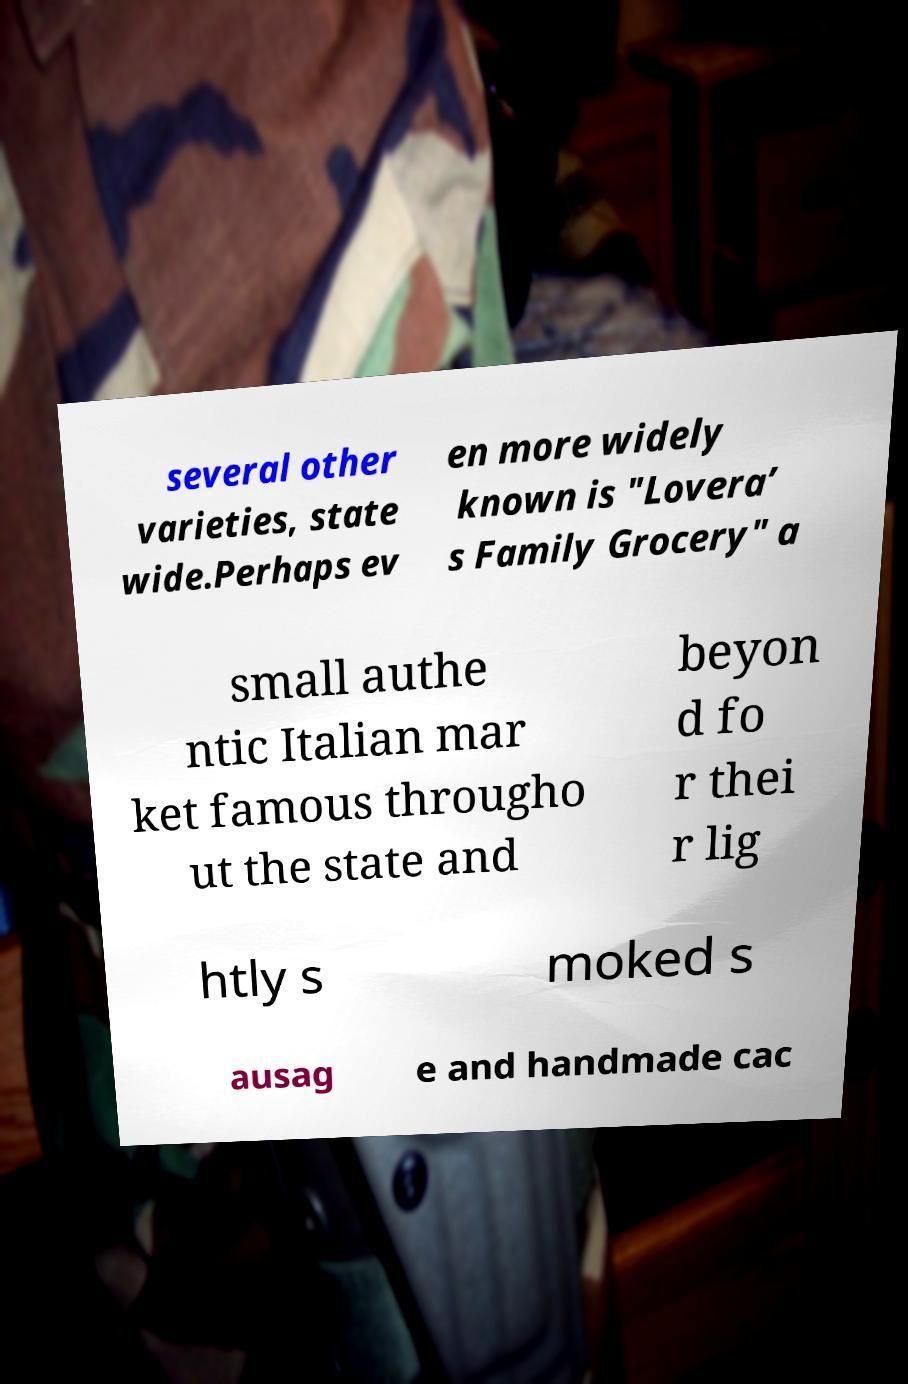Please read and relay the text visible in this image. What does it say? several other varieties, state wide.Perhaps ev en more widely known is "Lovera’ s Family Grocery" a small authe ntic Italian mar ket famous througho ut the state and beyon d fo r thei r lig htly s moked s ausag e and handmade cac 